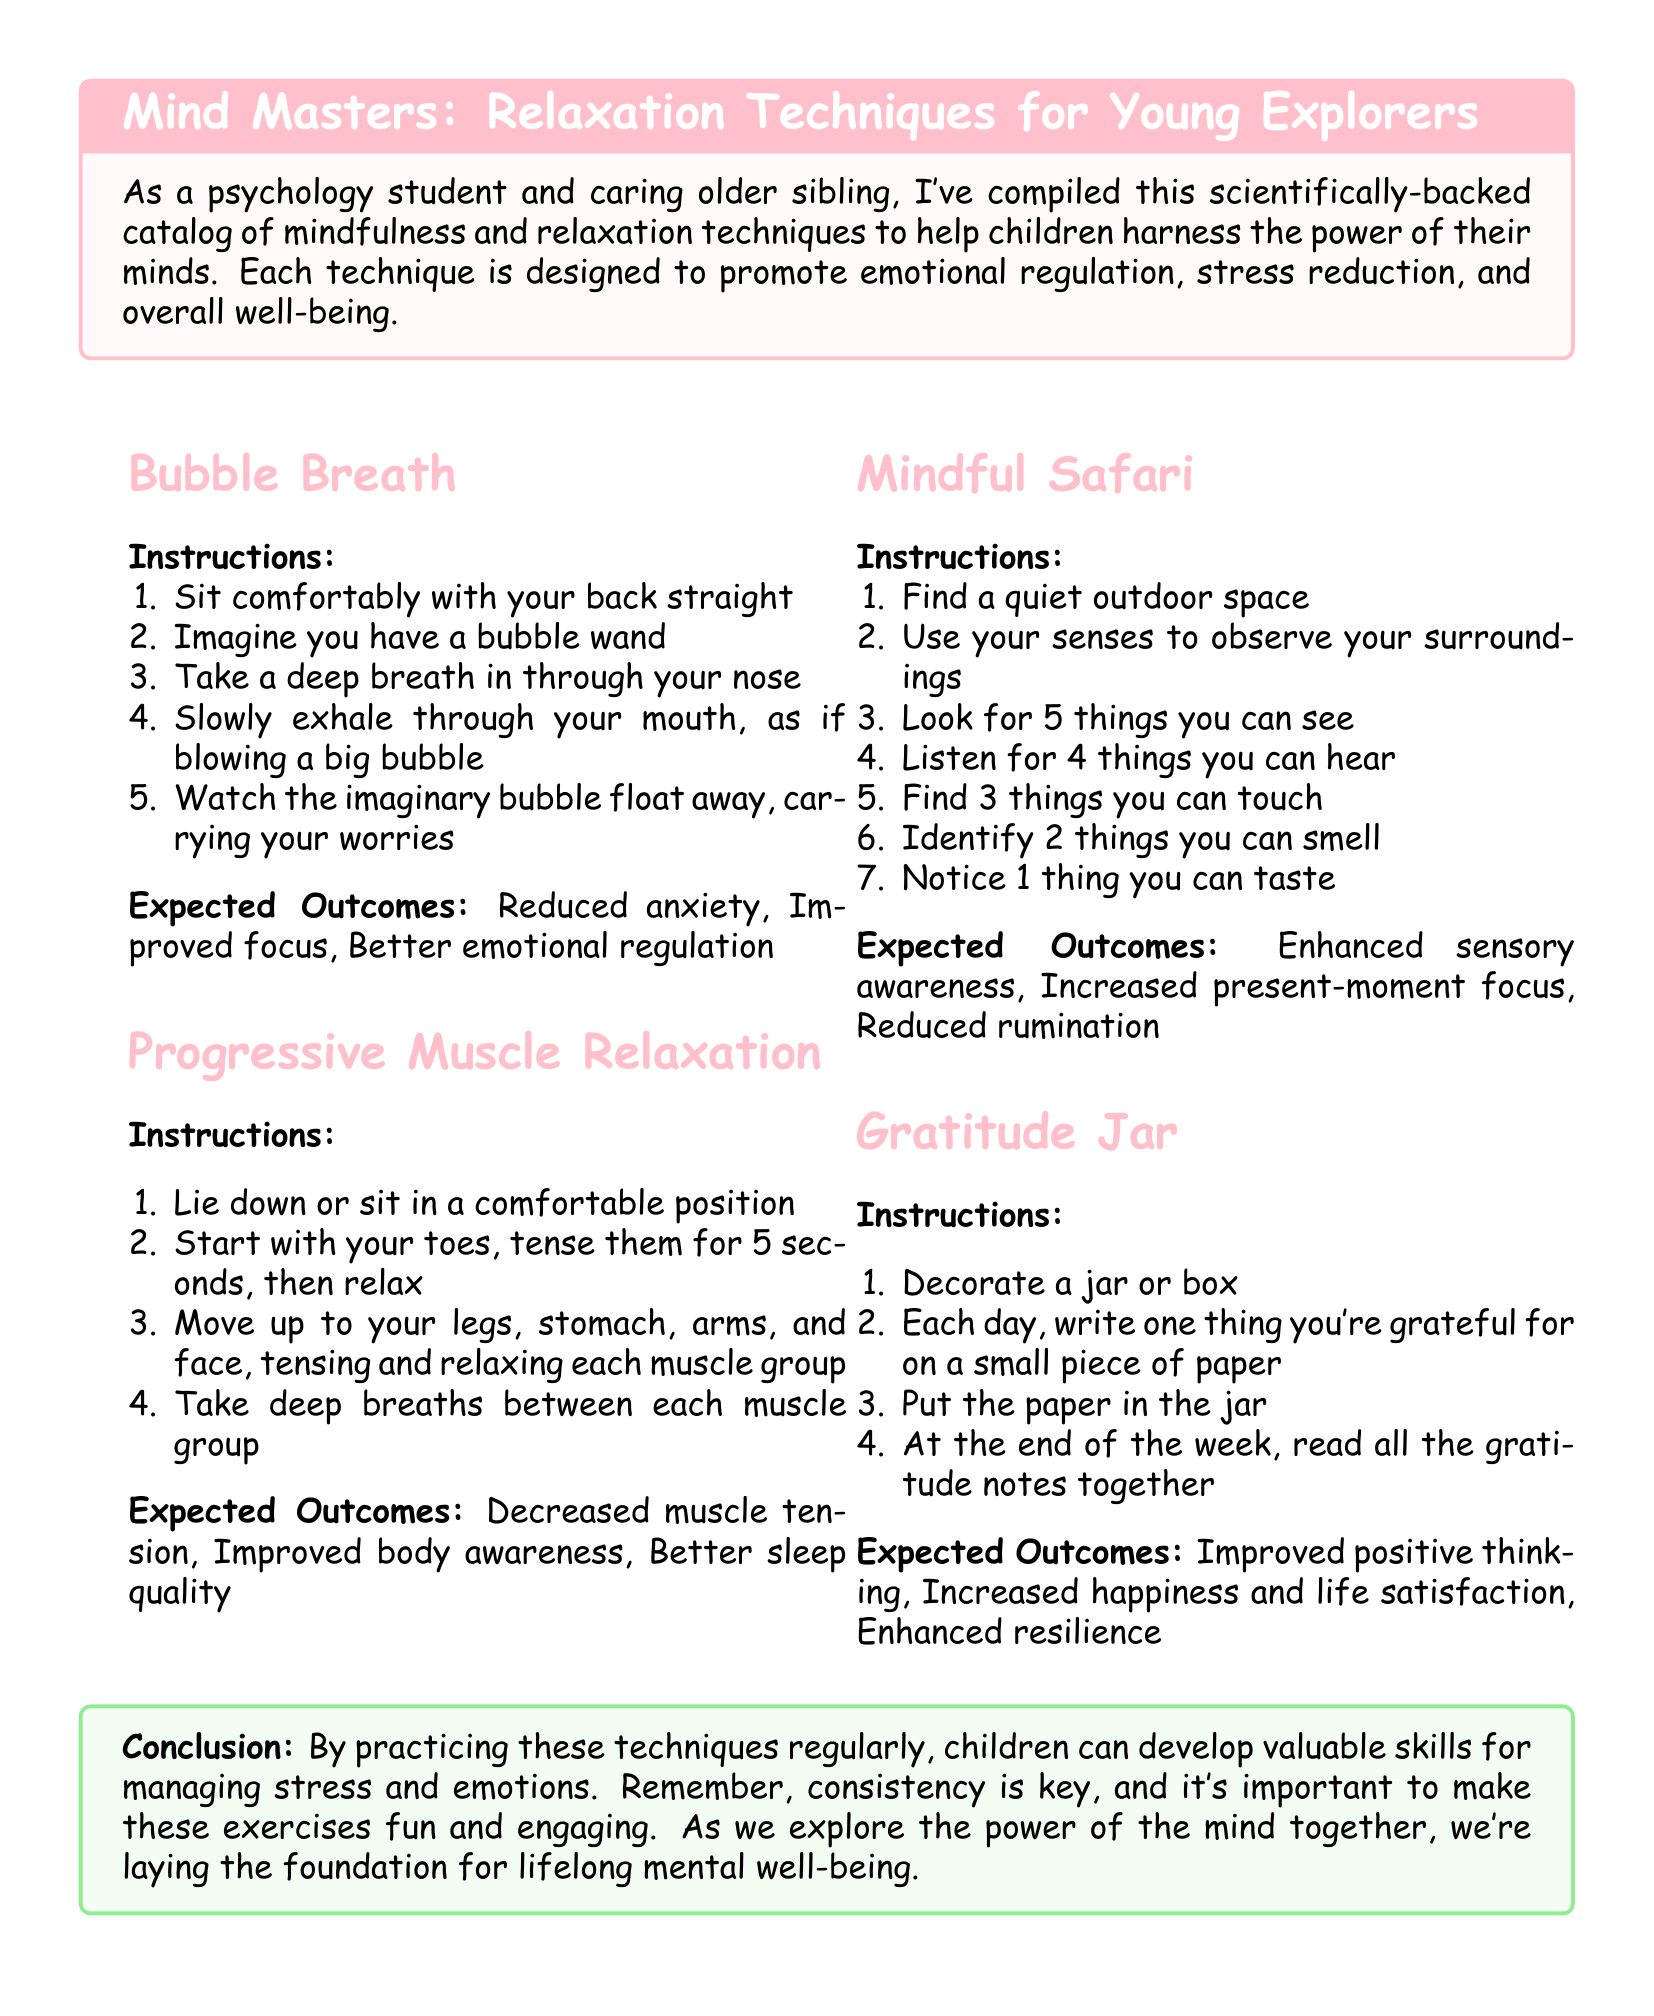What is the title of the catalog? The title is the main heading of the document, often indicating its purpose.
Answer: Mind Masters: Relaxation Techniques for Young Explorers How many techniques are listed in the document? The document outlines four mindfulness and relaxation techniques.
Answer: Four What is the expected outcome of the Bubble Breath technique? The expected outcomes are specifically related to the effects of the Bubble Breath technique on individuals.
Answer: Reduced anxiety What do you write in the Gratitude Jar? This item describes the content that is added to the jar as part of the gratitude practice.
Answer: One thing you're grateful for Which technique involves observing surroundings in nature? The technique focuses on enhancing sensory awareness in an outdoor setting.
Answer: Mindful Safari What is the primary benefit of practicing these techniques regularly? The document concludes with the main advantage of consistent practice of the mentioned techniques.
Answer: Lifelong mental well-being Which muscle group should you start with in Progressive Muscle Relaxation? The first muscle group to be addressed in this relaxation technique.
Answer: Toes How can you enhance positive thinking according to the document? The document includes a specific activity aimed at promoting positive thinking.
Answer: Gratitude Jar 